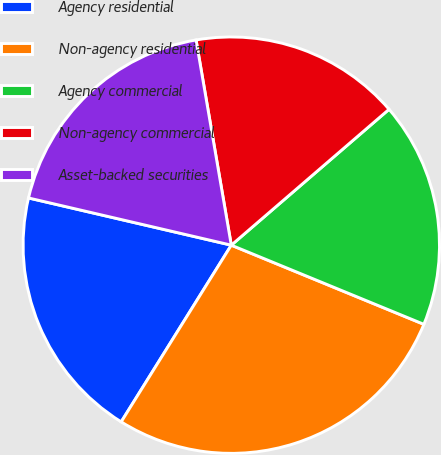<chart> <loc_0><loc_0><loc_500><loc_500><pie_chart><fcel>Agency residential<fcel>Non-agency residential<fcel>Agency commercial<fcel>Non-agency commercial<fcel>Asset-backed securities<nl><fcel>19.77%<fcel>27.66%<fcel>17.52%<fcel>16.39%<fcel>18.65%<nl></chart> 